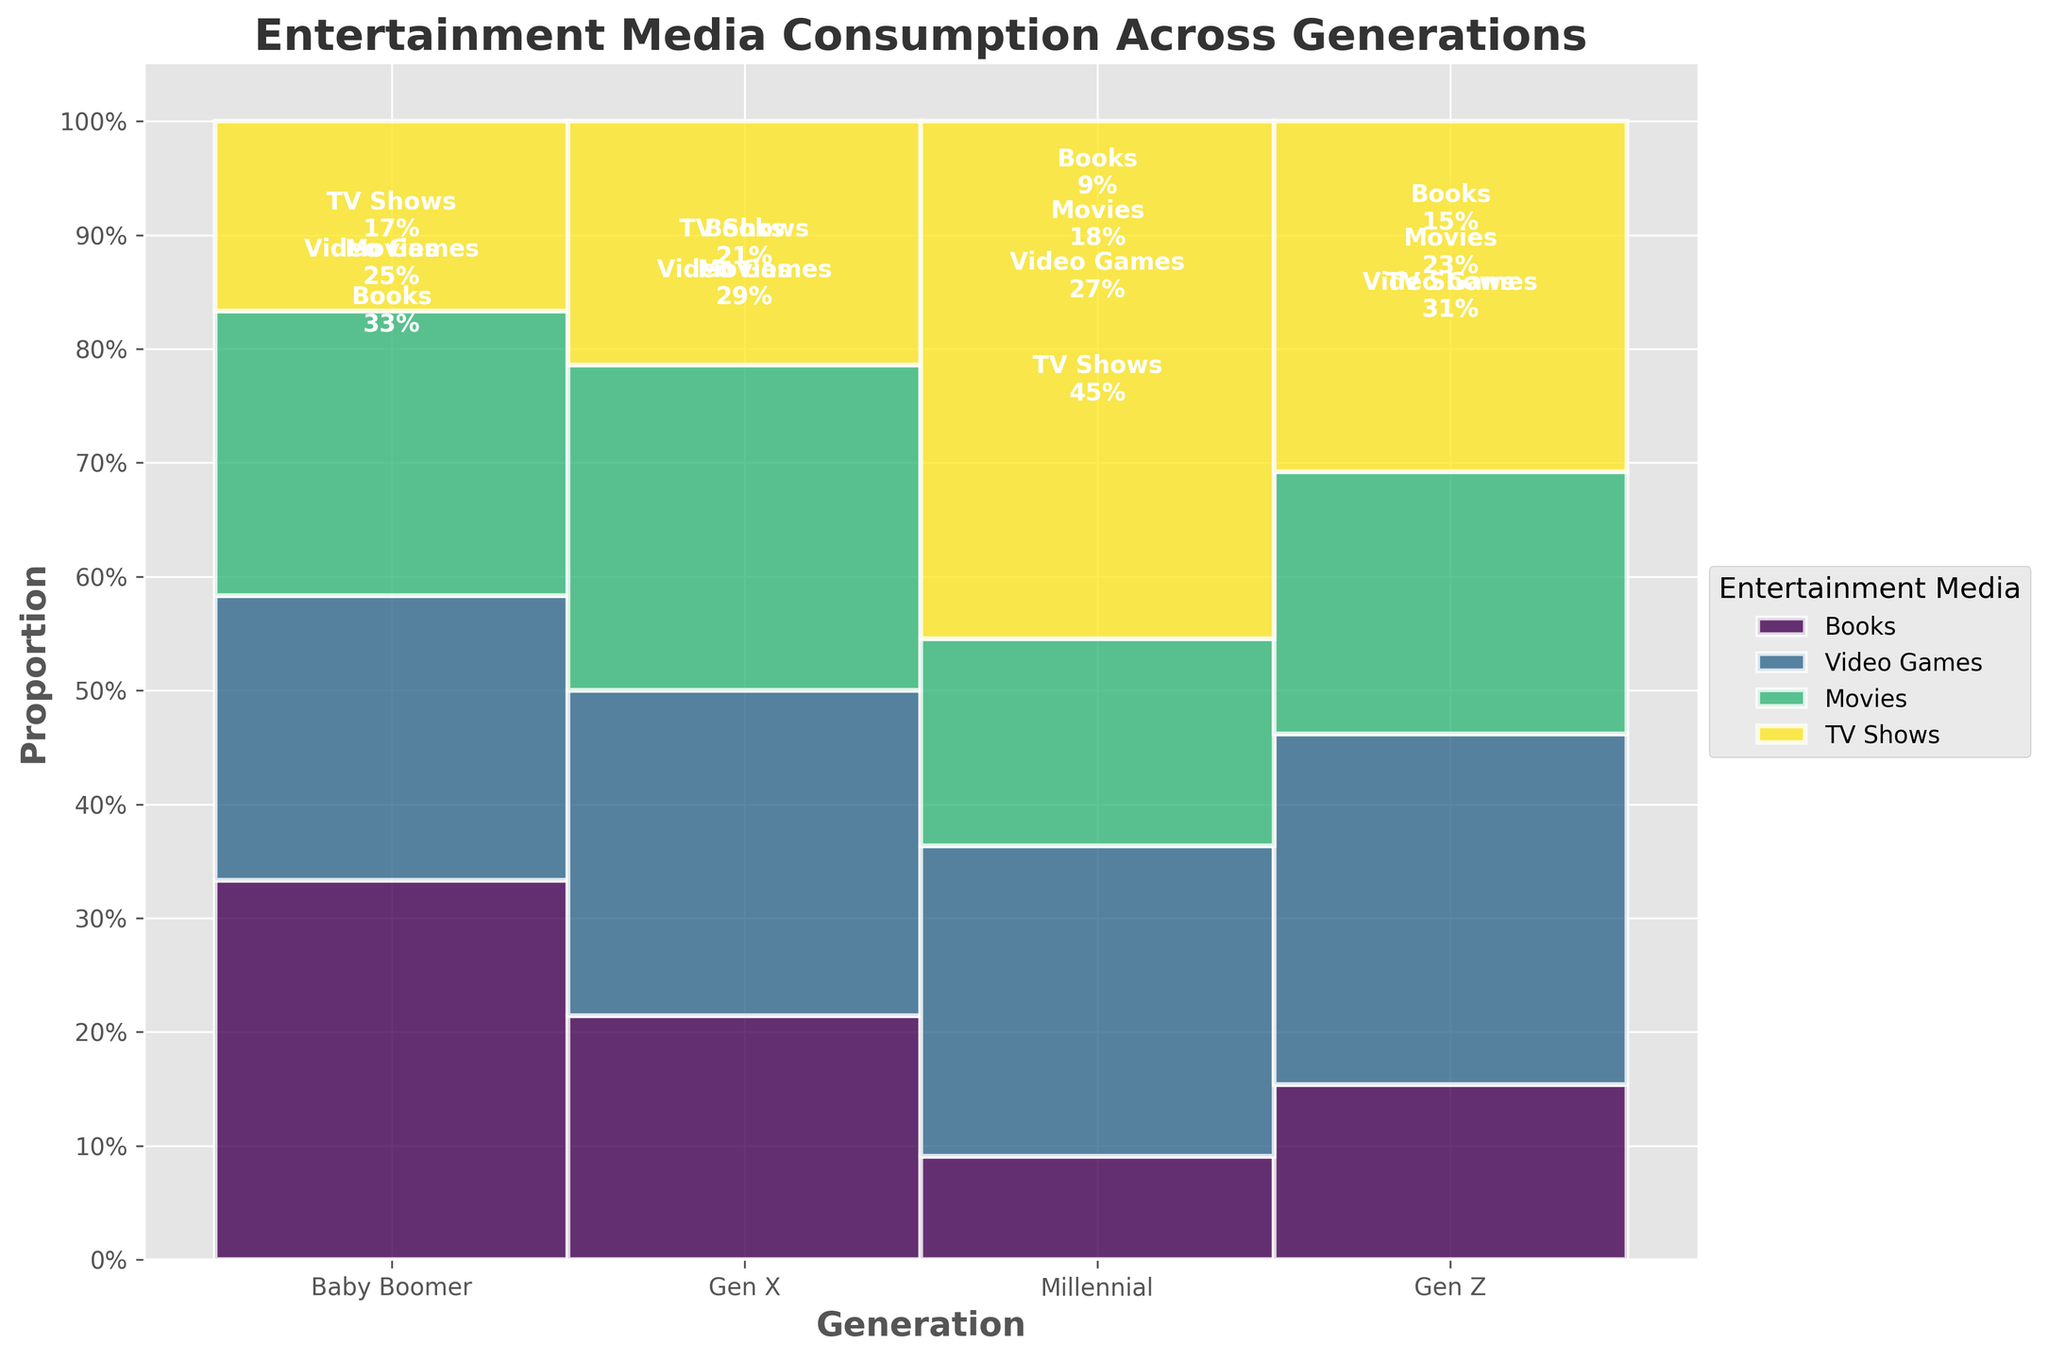What is the title of the plot? The title of the plot is found at the top and typically provides a summary of what the plot is illustrating. In this case, it mentions the consumption of entertainment media across generations in a family.
Answer: Entertainment Media Consumption Across Generations Which generation has the highest frequency of video game consumption? By analyzing the heights (proportions) of the sections labeled "Video Games" across different generations, the tallest section represents the highest frequency. This is seen in the "Gen Z" generation.
Answer: Gen Z How does the consumption of books compare between Baby Boomers and Gen Z? To find this, compare the height of the bar sections labeled "Books" for Baby Boomers and Gen Z. The "Books" section for Baby Boomers is significantly taller than for Gen Z.
Answer: Baby Boomers have much higher consumption Which type of media do Millennials consume the most? By looking at the tallest section within the Millennial generation, we can identify the media type. The tallest section is labeled "Video Games."
Answer: Video Games What is the most consumed type of media by Gen X? Similarly, for Gen X, the tallest section within this generation indicates the most consumed media type. This is labeled "Movies."
Answer: Movies What's the difference in TV show consumption between Gen X and Baby Boomers? Check the height of the "TV Shows" section for both generations. The height for Gen X is higher than for Baby Boomers. The proportional difference can be interpreted from the relative sizes.
Answer: Gen X consumes more TV shows than Baby Boomers Which generation has the lowest consumption of books? Look at the "Books" sections across all generations and identify the shortest one, which is seen for Gen Z.
Answer: Gen Z Who watches more movies: Millennials or Gen Z? Compare the heights of the "Movies" sections for Millennials and Gen Z. Both are labeled and can be compared visually; they are approximately the same.
Answer: Both Millennials and Gen Z What is the overall trend in video game consumption across generations? Notice the changes in the height of the "Video Games" sections from Baby Boomers to Gen Z. It increases with younger generations, moving from low to very high.
Answer: Increases Which generation balances their consumption across all media types the most evenly? Look for a generation where the bar sections are most similar in height. Gen X shows relatively balanced bar heights for all media types.
Answer: Gen X 